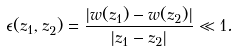Convert formula to latex. <formula><loc_0><loc_0><loc_500><loc_500>\epsilon ( z _ { 1 } , z _ { 2 } ) = \frac { | w ( z _ { 1 } ) - w ( z _ { 2 } ) | } { | z _ { 1 } - z _ { 2 } | } \ll 1 .</formula> 